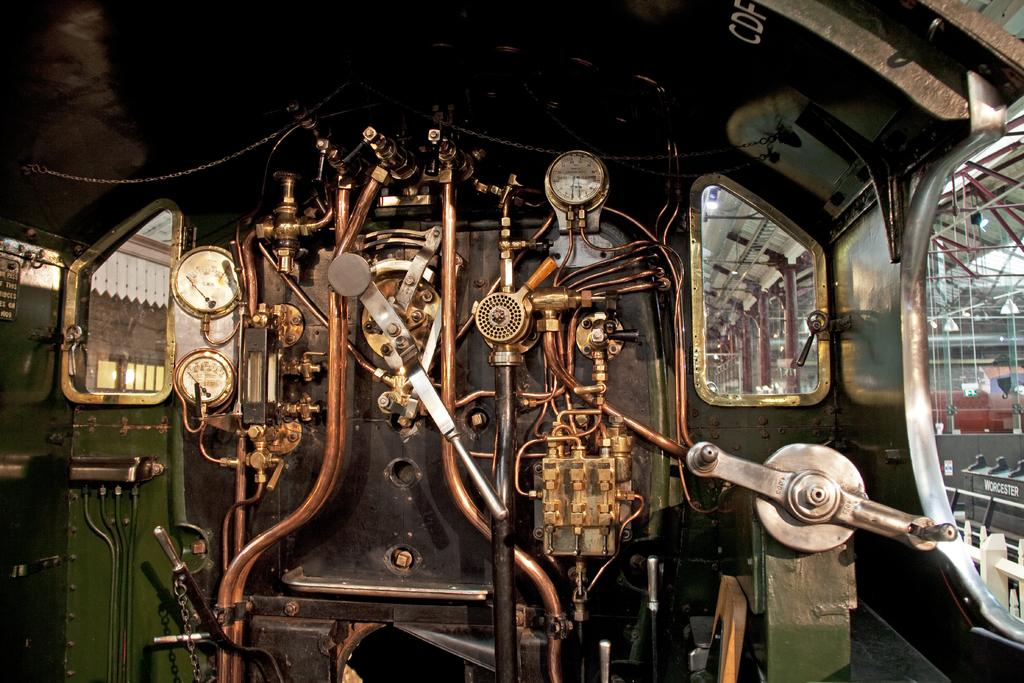What is the main subject of the image? The main subject of the image is a machine. Can you describe the machine in the image? The machine resembles the engine of a locomotive. What can be seen in the background of the image? There are red color pillars in the background of the image. Can you tell me how many squirrels are playing the game in the image? There are no squirrels or games present in the image; it features a machine that resembles a locomotive engine and red color pillars in the background. 